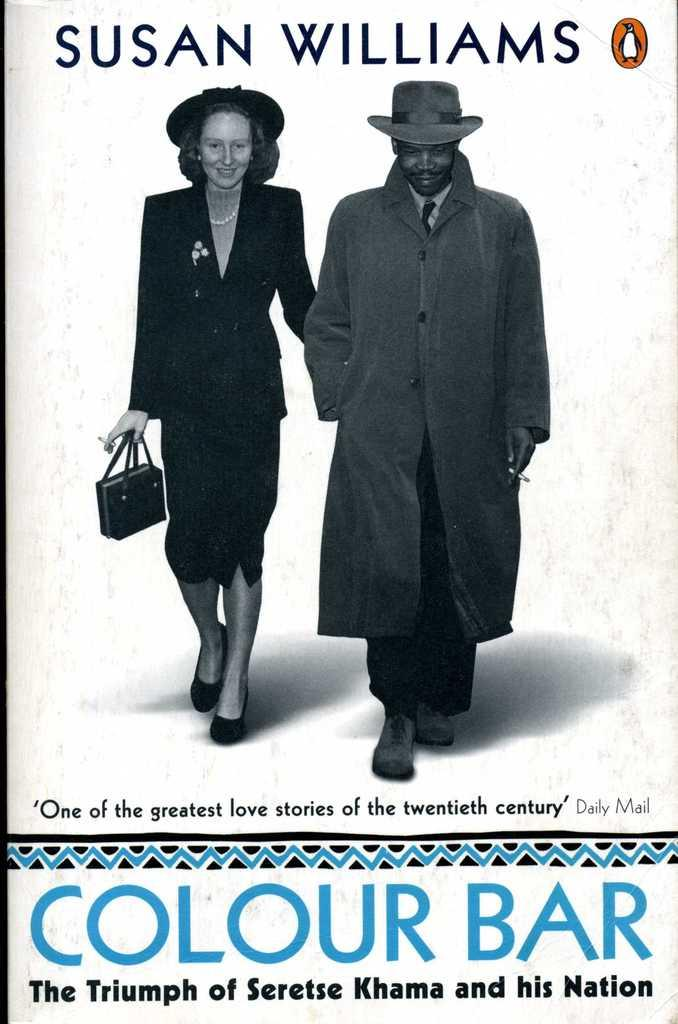What is the main subject of the poster in the image? The poster contains an image of a man and a woman. What are the man and woman wearing in the image? The man is wearing a coat and a hat, and the woman is also wearing a coat and a hat. Is there any text on the poster? Yes, there is text at the bottom of the poster. How many carts can be seen in the image? There are no carts present in the image. What color is the woman's nose in the image? The image does not provide information about the color of the woman's nose. 